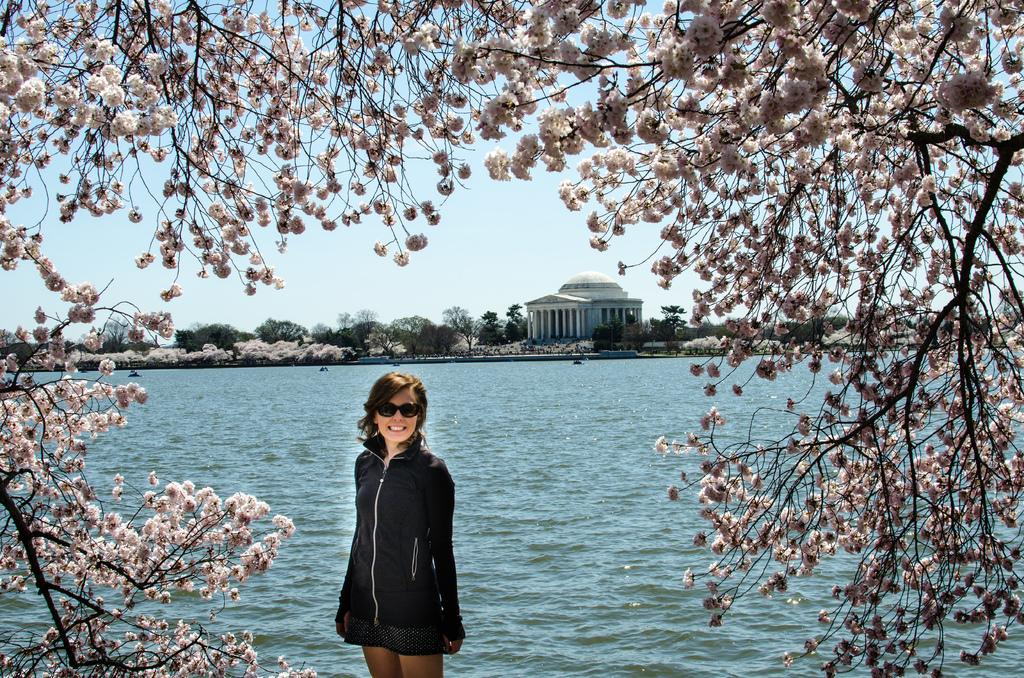What type of flowers can be seen in the image? There are blossoms in the image. Can you describe the person in the image? There is a woman standing in the image. What can be seen in the distance behind the woman? There are buildings, trees, water, and the sky visible in the background of the image. What type of vein is visible in the image? There is no vein visible in the image. Is there a bomb present in the image? No, there is no bomb present in the image. 